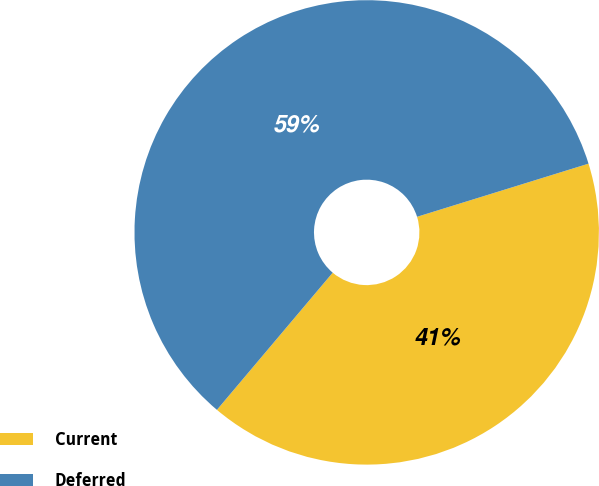Convert chart to OTSL. <chart><loc_0><loc_0><loc_500><loc_500><pie_chart><fcel>Current<fcel>Deferred<nl><fcel>40.94%<fcel>59.06%<nl></chart> 